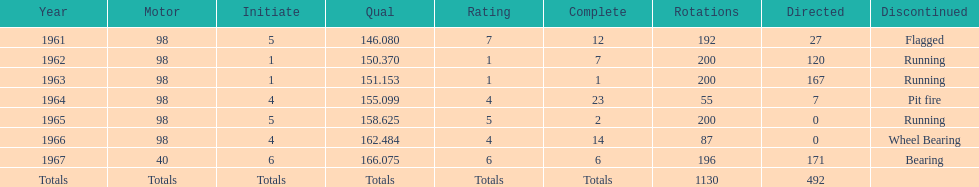Parse the full table. {'header': ['Year', 'Motor', 'Initiate', 'Qual', 'Rating', 'Complete', 'Rotations', 'Directed', 'Discontinued'], 'rows': [['1961', '98', '5', '146.080', '7', '12', '192', '27', 'Flagged'], ['1962', '98', '1', '150.370', '1', '7', '200', '120', 'Running'], ['1963', '98', '1', '151.153', '1', '1', '200', '167', 'Running'], ['1964', '98', '4', '155.099', '4', '23', '55', '7', 'Pit fire'], ['1965', '98', '5', '158.625', '5', '2', '200', '0', 'Running'], ['1966', '98', '4', '162.484', '4', '14', '87', '0', 'Wheel Bearing'], ['1967', '40', '6', '166.075', '6', '6', '196', '171', 'Bearing'], ['Totals', 'Totals', 'Totals', 'Totals', 'Totals', 'Totals', '1130', '492', '']]} Which car accomplished the peak standard? 40. 